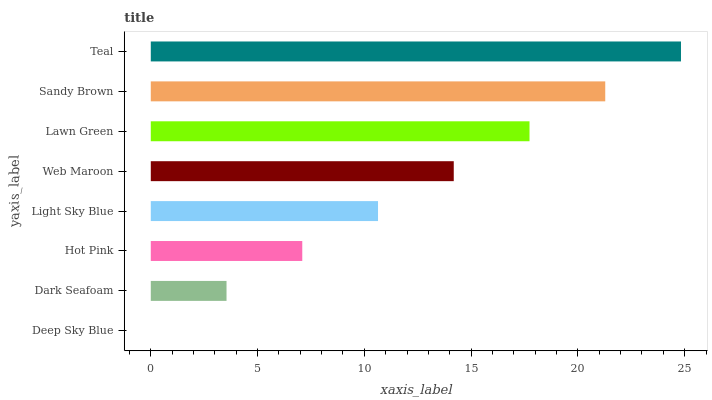Is Deep Sky Blue the minimum?
Answer yes or no. Yes. Is Teal the maximum?
Answer yes or no. Yes. Is Dark Seafoam the minimum?
Answer yes or no. No. Is Dark Seafoam the maximum?
Answer yes or no. No. Is Dark Seafoam greater than Deep Sky Blue?
Answer yes or no. Yes. Is Deep Sky Blue less than Dark Seafoam?
Answer yes or no. Yes. Is Deep Sky Blue greater than Dark Seafoam?
Answer yes or no. No. Is Dark Seafoam less than Deep Sky Blue?
Answer yes or no. No. Is Web Maroon the high median?
Answer yes or no. Yes. Is Light Sky Blue the low median?
Answer yes or no. Yes. Is Hot Pink the high median?
Answer yes or no. No. Is Sandy Brown the low median?
Answer yes or no. No. 